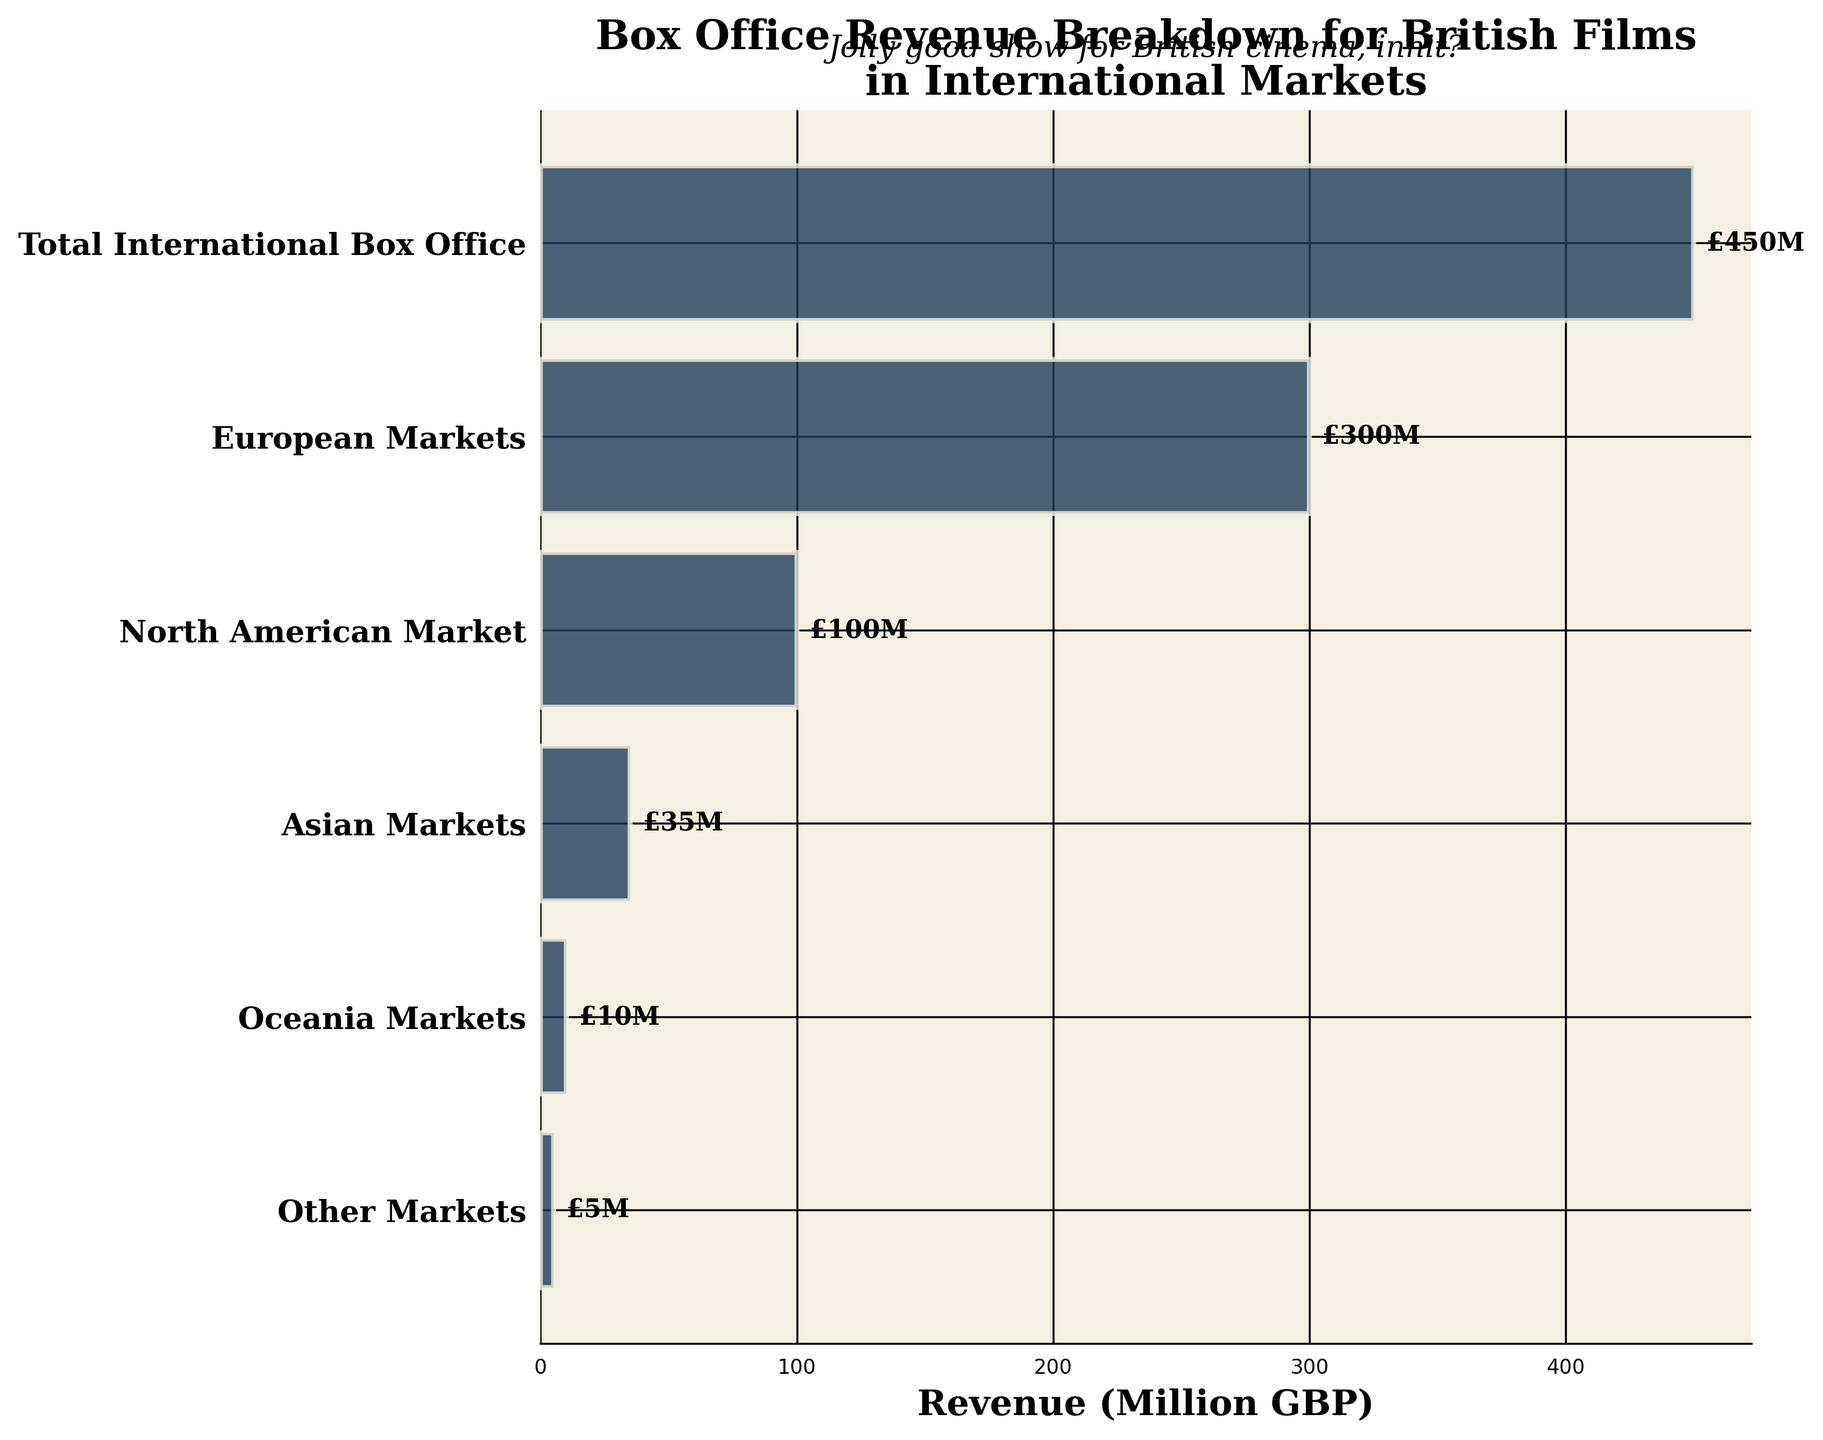What is the title of the figure? The title of the figure is displayed prominently at the top. It reads: "Box Office Revenue Breakdown for British Films in International Markets".
Answer: Box Office Revenue Breakdown for British Films in International Markets How much revenue is generated from European Markets? The European Markets' revenue value is shown on the horizontal bar corresponding to the European Markets label.
Answer: £300M What is the least revenue-generating market according to the chart? The smallest bar in the funnel chart represents the market generating the least revenue, which is labeled as Other Markets.
Answer: Other Markets What is the difference in revenue between the European and North American Markets? The revenue for European Markets is £300M, and for North American Market is £100M. The difference is calculated as £300M - £100M = £200M.
Answer: £200M Which market generates more revenue: Asian or Oceania Markets? By comparing the lengths of the bars labeled Asian Markets and Oceania Markets, it is clear that the Asian Markets' bar is longer.
Answer: Asian Markets How many stages are displayed in the funnel chart? Count the number of horizontal bars/labels starting from the top (Total International Box Office) to the bottom (Other Markets).
Answer: 6 What is the subtotal of revenues from North American and Asian Markets combined? Add the revenue values for North American Market (£100M) and Asian Markets (£35M). The subtotal is calculated as £100M + £35M = £135M.
Answer: £135M By how much does the revenue from Asian Markets exceed that from Oceania Markets? The revenue from Asian Markets is £35M and from Oceania Markets is £10M. The difference is calculated as £35M - £10M = £25M.
Answer: £25M What percentage of the total international box office revenue comes from the European Markets? Calculate the percentage by dividing the European Markets revenue (300) by the total international box office revenue (450) and then multiplying by 100. (300 / 450) * 100 = 66.67%.
Answer: 66.67% Explain the overall revenue trend as you go from Total International Box Office to Other Markets. The bars in the funnel chart get progressively smaller going from the top stage, Total International Box Office, to the bottom stage, Other Markets. This indicates that the revenue decreases at each subsequent stage.
Answer: Revenue decreases at each subsequent stage 